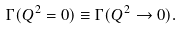Convert formula to latex. <formula><loc_0><loc_0><loc_500><loc_500>\Gamma ( Q ^ { 2 } = 0 ) \equiv \Gamma ( Q ^ { 2 } \rightarrow 0 ) .</formula> 